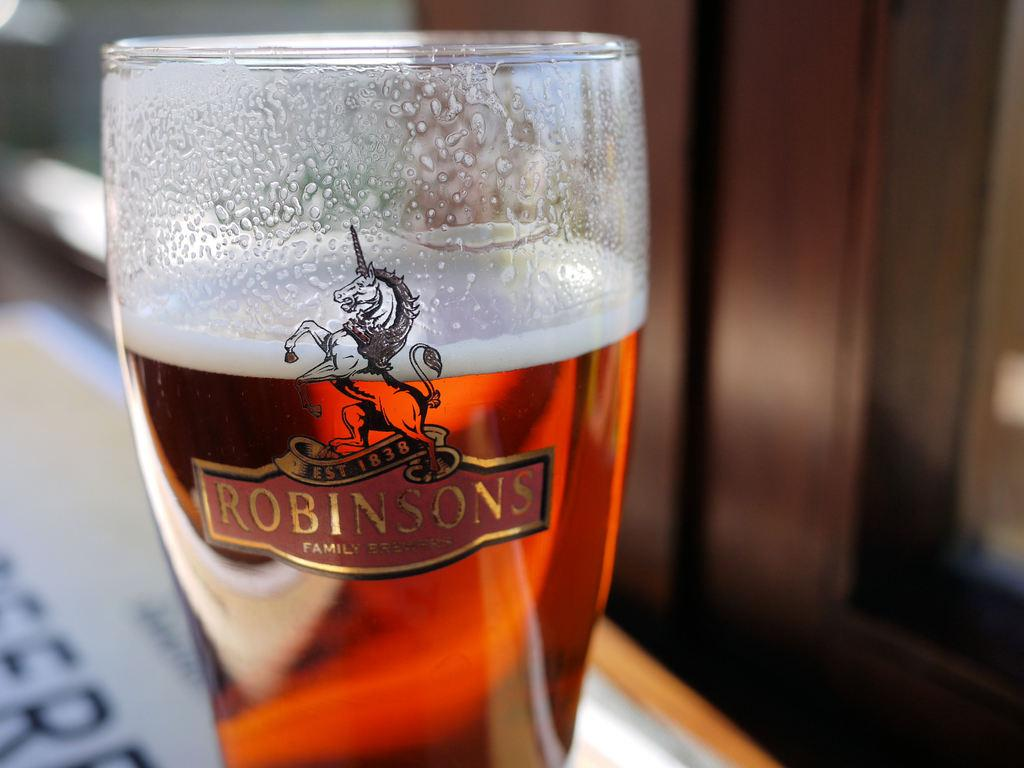<image>
Give a short and clear explanation of the subsequent image. Robinsons Family Brewers Cup that is established in 1838. 